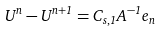Convert formula to latex. <formula><loc_0><loc_0><loc_500><loc_500>U ^ { n } - U ^ { n + 1 } = C _ { s , 1 } A ^ { - 1 } e _ { n }</formula> 